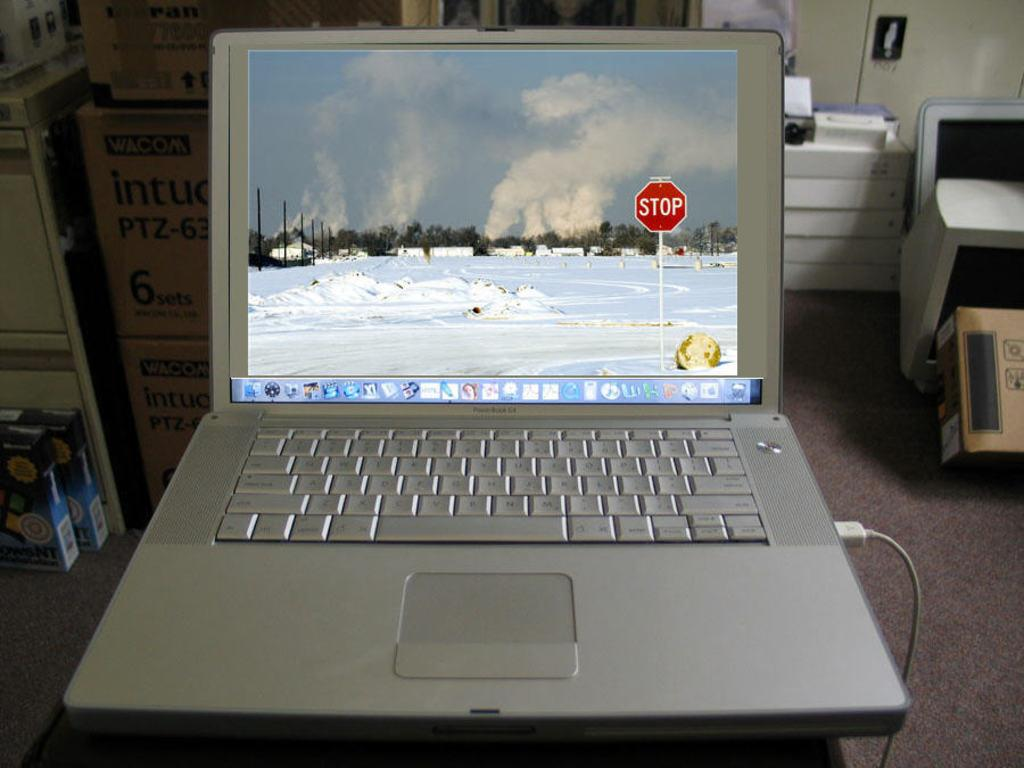Provide a one-sentence caption for the provided image. A laptop is powered on and displays a snow covered area with a stop sign. 